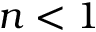<formula> <loc_0><loc_0><loc_500><loc_500>n < 1</formula> 